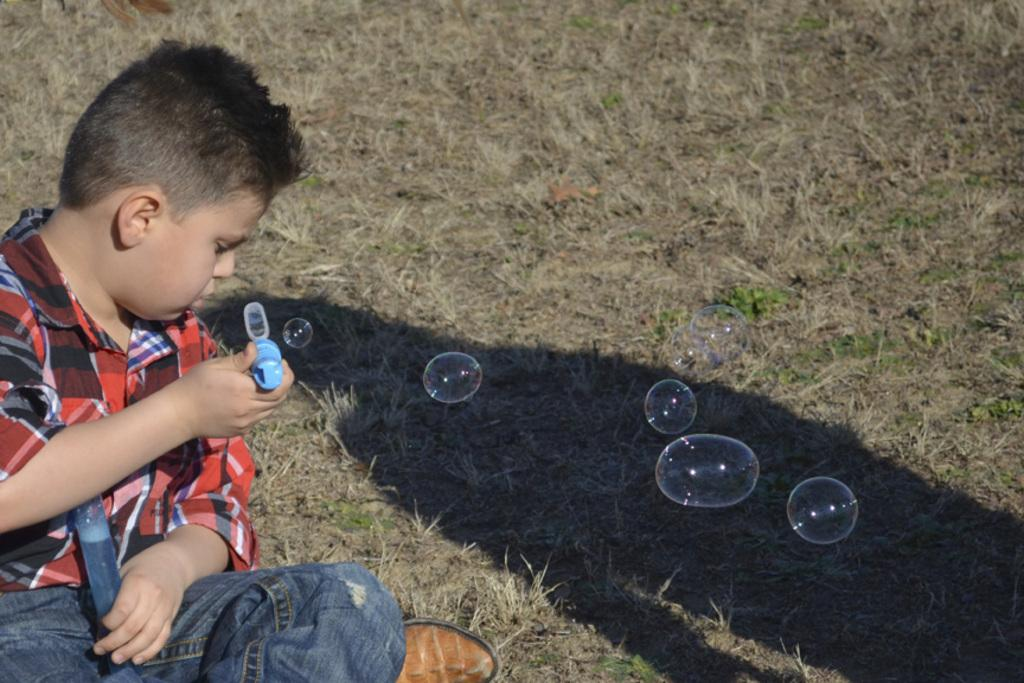What type of vegetation is present in the image? There is grass in the image. Who is in the image? There is a boy in the image. What is the boy doing in the image? The boy is blowing bubbles. Can you tell me how many chickens are in the image? There are no chickens present in the image. What type of arithmetic problem is the boy solving in the image? There is no arithmetic problem visible in the image; the boy is blowing bubbles. 